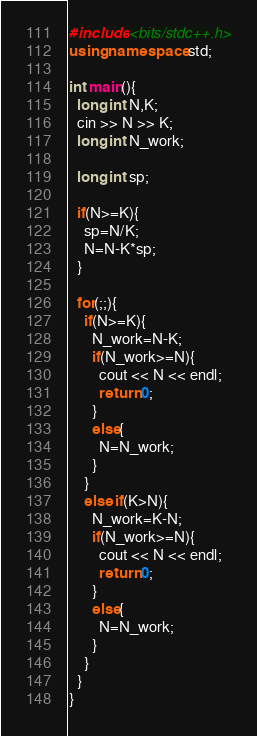<code> <loc_0><loc_0><loc_500><loc_500><_C++_>#include <bits/stdc++.h>
using namespace std;

int main(){
  long int N,K;
  cin >> N >> K;
  long int N_work;
  
  long int sp;

  if(N>=K){
    sp=N/K;
    N=N-K*sp;
  }
  
  for(;;){
    if(N>=K){
      N_work=N-K;
      if(N_work>=N){
        cout << N << endl;
        return 0;
      }
      else{
        N=N_work;
      }
    }
    else if(K>N){
      N_work=K-N;
      if(N_work>=N){
        cout << N << endl;
        return 0;
      }
      else{
        N=N_work;
      }
    }
  }
}</code> 